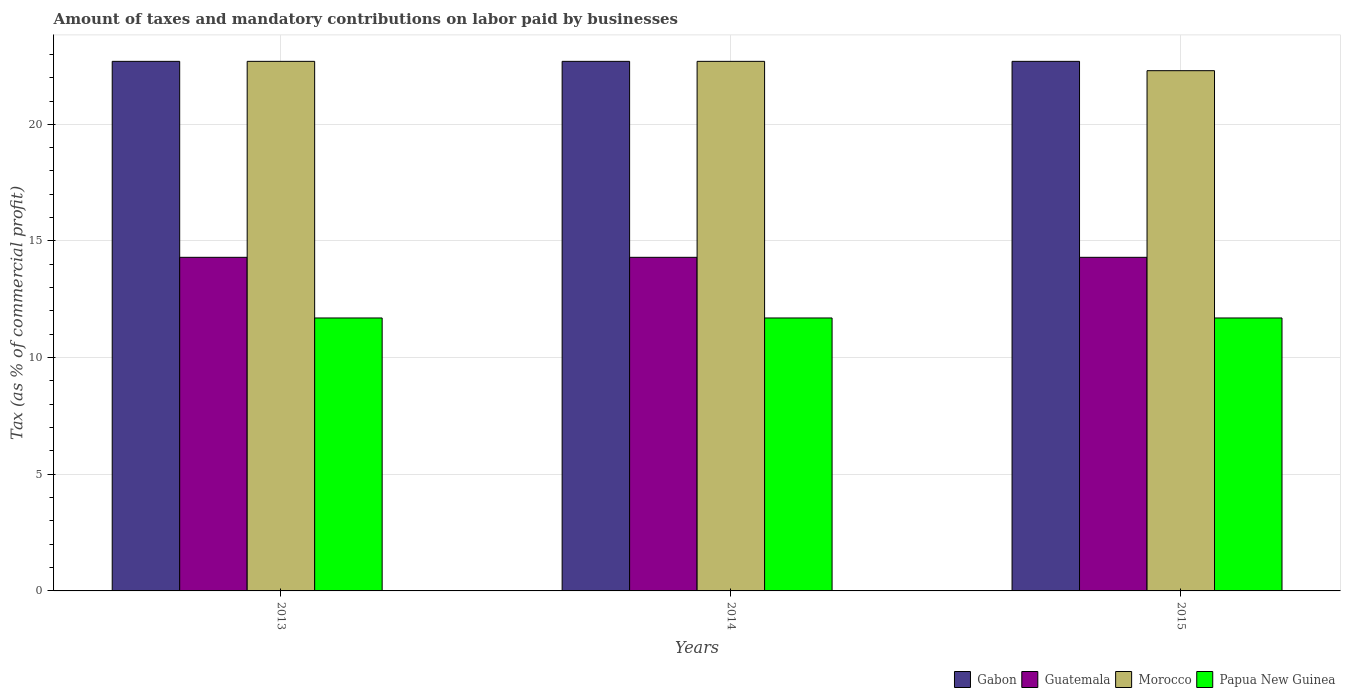Are the number of bars on each tick of the X-axis equal?
Provide a succinct answer. Yes. How many bars are there on the 2nd tick from the left?
Provide a short and direct response. 4. How many bars are there on the 2nd tick from the right?
Your answer should be very brief. 4. In how many cases, is the number of bars for a given year not equal to the number of legend labels?
Your response must be concise. 0. What is the percentage of taxes paid by businesses in Papua New Guinea in 2014?
Give a very brief answer. 11.7. Across all years, what is the maximum percentage of taxes paid by businesses in Morocco?
Offer a terse response. 22.7. Across all years, what is the minimum percentage of taxes paid by businesses in Guatemala?
Offer a very short reply. 14.3. In which year was the percentage of taxes paid by businesses in Morocco minimum?
Ensure brevity in your answer.  2015. What is the total percentage of taxes paid by businesses in Gabon in the graph?
Provide a succinct answer. 68.1. What is the difference between the percentage of taxes paid by businesses in Morocco in 2013 and that in 2015?
Your answer should be compact. 0.4. What is the difference between the percentage of taxes paid by businesses in Papua New Guinea in 2015 and the percentage of taxes paid by businesses in Morocco in 2014?
Offer a terse response. -11. What is the average percentage of taxes paid by businesses in Morocco per year?
Provide a short and direct response. 22.57. In the year 2014, what is the difference between the percentage of taxes paid by businesses in Morocco and percentage of taxes paid by businesses in Papua New Guinea?
Provide a succinct answer. 11. In how many years, is the percentage of taxes paid by businesses in Morocco greater than 10 %?
Your answer should be compact. 3. What is the ratio of the percentage of taxes paid by businesses in Gabon in 2013 to that in 2014?
Your answer should be compact. 1. What is the difference between the highest and the second highest percentage of taxes paid by businesses in Papua New Guinea?
Keep it short and to the point. 0. What is the difference between the highest and the lowest percentage of taxes paid by businesses in Papua New Guinea?
Offer a very short reply. 0. In how many years, is the percentage of taxes paid by businesses in Guatemala greater than the average percentage of taxes paid by businesses in Guatemala taken over all years?
Your answer should be very brief. 0. Is the sum of the percentage of taxes paid by businesses in Gabon in 2013 and 2014 greater than the maximum percentage of taxes paid by businesses in Papua New Guinea across all years?
Provide a short and direct response. Yes. What does the 4th bar from the left in 2013 represents?
Offer a very short reply. Papua New Guinea. What does the 4th bar from the right in 2013 represents?
Offer a terse response. Gabon. Are all the bars in the graph horizontal?
Ensure brevity in your answer.  No. How many years are there in the graph?
Ensure brevity in your answer.  3. What is the difference between two consecutive major ticks on the Y-axis?
Ensure brevity in your answer.  5. Are the values on the major ticks of Y-axis written in scientific E-notation?
Provide a succinct answer. No. Does the graph contain any zero values?
Make the answer very short. No. Does the graph contain grids?
Your answer should be compact. Yes. Where does the legend appear in the graph?
Make the answer very short. Bottom right. How many legend labels are there?
Keep it short and to the point. 4. What is the title of the graph?
Make the answer very short. Amount of taxes and mandatory contributions on labor paid by businesses. What is the label or title of the Y-axis?
Your answer should be very brief. Tax (as % of commercial profit). What is the Tax (as % of commercial profit) in Gabon in 2013?
Offer a very short reply. 22.7. What is the Tax (as % of commercial profit) in Guatemala in 2013?
Your answer should be very brief. 14.3. What is the Tax (as % of commercial profit) in Morocco in 2013?
Offer a terse response. 22.7. What is the Tax (as % of commercial profit) of Papua New Guinea in 2013?
Give a very brief answer. 11.7. What is the Tax (as % of commercial profit) of Gabon in 2014?
Your answer should be very brief. 22.7. What is the Tax (as % of commercial profit) of Guatemala in 2014?
Your answer should be very brief. 14.3. What is the Tax (as % of commercial profit) in Morocco in 2014?
Give a very brief answer. 22.7. What is the Tax (as % of commercial profit) in Papua New Guinea in 2014?
Keep it short and to the point. 11.7. What is the Tax (as % of commercial profit) of Gabon in 2015?
Provide a short and direct response. 22.7. What is the Tax (as % of commercial profit) of Guatemala in 2015?
Your answer should be compact. 14.3. What is the Tax (as % of commercial profit) of Morocco in 2015?
Offer a terse response. 22.3. Across all years, what is the maximum Tax (as % of commercial profit) of Gabon?
Your answer should be very brief. 22.7. Across all years, what is the maximum Tax (as % of commercial profit) in Morocco?
Offer a very short reply. 22.7. Across all years, what is the maximum Tax (as % of commercial profit) of Papua New Guinea?
Make the answer very short. 11.7. Across all years, what is the minimum Tax (as % of commercial profit) in Gabon?
Your answer should be very brief. 22.7. Across all years, what is the minimum Tax (as % of commercial profit) of Guatemala?
Provide a succinct answer. 14.3. Across all years, what is the minimum Tax (as % of commercial profit) in Morocco?
Give a very brief answer. 22.3. Across all years, what is the minimum Tax (as % of commercial profit) of Papua New Guinea?
Provide a succinct answer. 11.7. What is the total Tax (as % of commercial profit) of Gabon in the graph?
Provide a succinct answer. 68.1. What is the total Tax (as % of commercial profit) of Guatemala in the graph?
Offer a very short reply. 42.9. What is the total Tax (as % of commercial profit) in Morocco in the graph?
Keep it short and to the point. 67.7. What is the total Tax (as % of commercial profit) of Papua New Guinea in the graph?
Offer a terse response. 35.1. What is the difference between the Tax (as % of commercial profit) in Guatemala in 2013 and that in 2014?
Ensure brevity in your answer.  0. What is the difference between the Tax (as % of commercial profit) of Papua New Guinea in 2013 and that in 2014?
Provide a short and direct response. 0. What is the difference between the Tax (as % of commercial profit) of Gabon in 2013 and that in 2015?
Offer a terse response. 0. What is the difference between the Tax (as % of commercial profit) of Guatemala in 2013 and that in 2015?
Ensure brevity in your answer.  0. What is the difference between the Tax (as % of commercial profit) of Gabon in 2013 and the Tax (as % of commercial profit) of Guatemala in 2014?
Offer a terse response. 8.4. What is the difference between the Tax (as % of commercial profit) in Gabon in 2013 and the Tax (as % of commercial profit) in Morocco in 2014?
Offer a terse response. 0. What is the difference between the Tax (as % of commercial profit) of Gabon in 2013 and the Tax (as % of commercial profit) of Papua New Guinea in 2014?
Offer a terse response. 11. What is the difference between the Tax (as % of commercial profit) in Guatemala in 2013 and the Tax (as % of commercial profit) in Papua New Guinea in 2015?
Offer a terse response. 2.6. What is the difference between the Tax (as % of commercial profit) of Gabon in 2014 and the Tax (as % of commercial profit) of Guatemala in 2015?
Your answer should be compact. 8.4. What is the difference between the Tax (as % of commercial profit) in Gabon in 2014 and the Tax (as % of commercial profit) in Papua New Guinea in 2015?
Provide a succinct answer. 11. What is the difference between the Tax (as % of commercial profit) of Guatemala in 2014 and the Tax (as % of commercial profit) of Morocco in 2015?
Ensure brevity in your answer.  -8. What is the difference between the Tax (as % of commercial profit) in Guatemala in 2014 and the Tax (as % of commercial profit) in Papua New Guinea in 2015?
Give a very brief answer. 2.6. What is the difference between the Tax (as % of commercial profit) of Morocco in 2014 and the Tax (as % of commercial profit) of Papua New Guinea in 2015?
Ensure brevity in your answer.  11. What is the average Tax (as % of commercial profit) of Gabon per year?
Provide a succinct answer. 22.7. What is the average Tax (as % of commercial profit) of Morocco per year?
Provide a succinct answer. 22.57. What is the average Tax (as % of commercial profit) of Papua New Guinea per year?
Provide a succinct answer. 11.7. In the year 2013, what is the difference between the Tax (as % of commercial profit) of Gabon and Tax (as % of commercial profit) of Guatemala?
Keep it short and to the point. 8.4. In the year 2013, what is the difference between the Tax (as % of commercial profit) in Gabon and Tax (as % of commercial profit) in Morocco?
Provide a succinct answer. 0. In the year 2013, what is the difference between the Tax (as % of commercial profit) of Gabon and Tax (as % of commercial profit) of Papua New Guinea?
Provide a short and direct response. 11. In the year 2013, what is the difference between the Tax (as % of commercial profit) of Guatemala and Tax (as % of commercial profit) of Papua New Guinea?
Ensure brevity in your answer.  2.6. In the year 2013, what is the difference between the Tax (as % of commercial profit) of Morocco and Tax (as % of commercial profit) of Papua New Guinea?
Your response must be concise. 11. In the year 2014, what is the difference between the Tax (as % of commercial profit) in Morocco and Tax (as % of commercial profit) in Papua New Guinea?
Offer a very short reply. 11. In the year 2015, what is the difference between the Tax (as % of commercial profit) of Gabon and Tax (as % of commercial profit) of Guatemala?
Give a very brief answer. 8.4. In the year 2015, what is the difference between the Tax (as % of commercial profit) in Gabon and Tax (as % of commercial profit) in Morocco?
Your answer should be very brief. 0.4. In the year 2015, what is the difference between the Tax (as % of commercial profit) in Gabon and Tax (as % of commercial profit) in Papua New Guinea?
Offer a terse response. 11. In the year 2015, what is the difference between the Tax (as % of commercial profit) of Morocco and Tax (as % of commercial profit) of Papua New Guinea?
Provide a succinct answer. 10.6. What is the ratio of the Tax (as % of commercial profit) in Guatemala in 2013 to that in 2014?
Your answer should be very brief. 1. What is the ratio of the Tax (as % of commercial profit) of Gabon in 2013 to that in 2015?
Provide a short and direct response. 1. What is the ratio of the Tax (as % of commercial profit) of Morocco in 2013 to that in 2015?
Make the answer very short. 1.02. What is the ratio of the Tax (as % of commercial profit) of Gabon in 2014 to that in 2015?
Provide a short and direct response. 1. What is the ratio of the Tax (as % of commercial profit) in Guatemala in 2014 to that in 2015?
Offer a very short reply. 1. What is the ratio of the Tax (as % of commercial profit) in Morocco in 2014 to that in 2015?
Give a very brief answer. 1.02. What is the ratio of the Tax (as % of commercial profit) in Papua New Guinea in 2014 to that in 2015?
Offer a very short reply. 1. What is the difference between the highest and the second highest Tax (as % of commercial profit) in Gabon?
Make the answer very short. 0. What is the difference between the highest and the second highest Tax (as % of commercial profit) in Guatemala?
Offer a terse response. 0. What is the difference between the highest and the second highest Tax (as % of commercial profit) of Morocco?
Provide a succinct answer. 0. What is the difference between the highest and the lowest Tax (as % of commercial profit) in Papua New Guinea?
Your answer should be very brief. 0. 